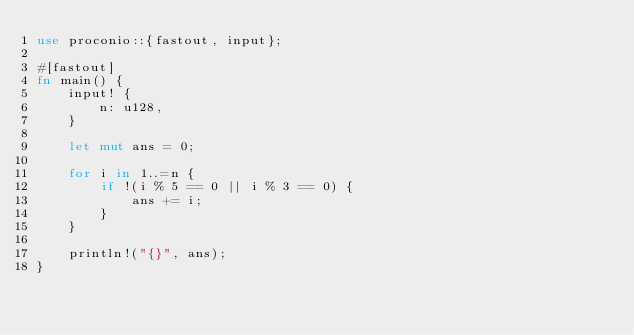Convert code to text. <code><loc_0><loc_0><loc_500><loc_500><_Rust_>use proconio::{fastout, input};

#[fastout]
fn main() {
    input! {
        n: u128,
    }

    let mut ans = 0;

    for i in 1..=n {
        if !(i % 5 == 0 || i % 3 == 0) {
            ans += i;
        }
    }

    println!("{}", ans);
}
</code> 